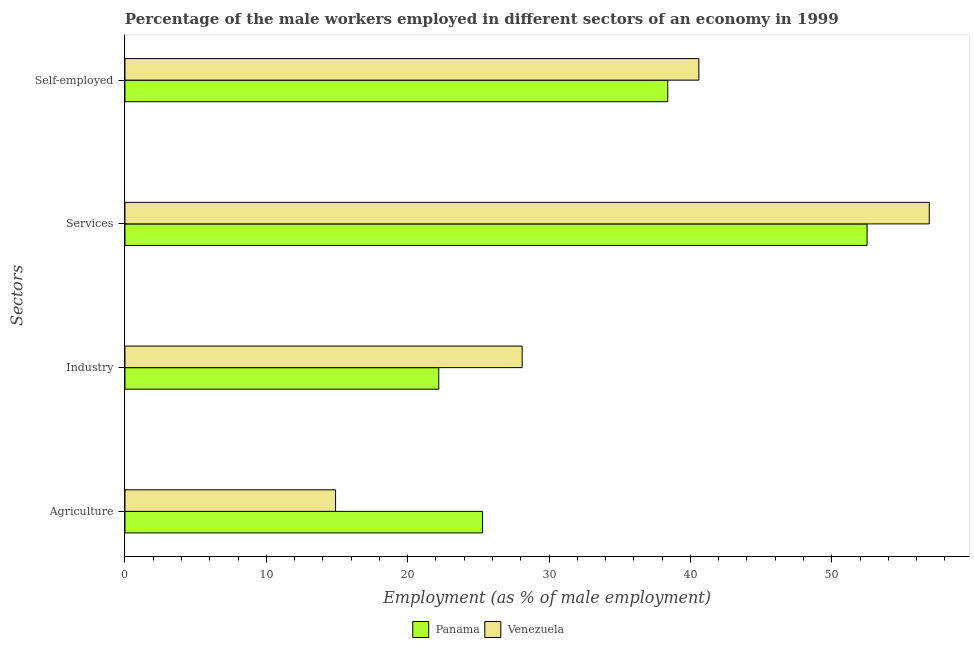How many different coloured bars are there?
Make the answer very short. 2. How many groups of bars are there?
Make the answer very short. 4. Are the number of bars on each tick of the Y-axis equal?
Provide a short and direct response. Yes. How many bars are there on the 3rd tick from the bottom?
Offer a terse response. 2. What is the label of the 3rd group of bars from the top?
Ensure brevity in your answer.  Industry. What is the percentage of male workers in industry in Panama?
Provide a short and direct response. 22.2. Across all countries, what is the maximum percentage of male workers in agriculture?
Your answer should be compact. 25.3. Across all countries, what is the minimum percentage of male workers in services?
Provide a short and direct response. 52.5. In which country was the percentage of male workers in industry maximum?
Offer a terse response. Venezuela. In which country was the percentage of self employed male workers minimum?
Offer a terse response. Panama. What is the total percentage of self employed male workers in the graph?
Your answer should be very brief. 79. What is the difference between the percentage of male workers in agriculture in Panama and that in Venezuela?
Your answer should be compact. 10.4. What is the difference between the percentage of male workers in services in Panama and the percentage of self employed male workers in Venezuela?
Make the answer very short. 11.9. What is the average percentage of male workers in services per country?
Keep it short and to the point. 54.7. What is the difference between the percentage of male workers in agriculture and percentage of male workers in industry in Venezuela?
Keep it short and to the point. -13.2. In how many countries, is the percentage of male workers in agriculture greater than 12 %?
Your answer should be very brief. 2. What is the ratio of the percentage of male workers in industry in Panama to that in Venezuela?
Give a very brief answer. 0.79. Is the percentage of male workers in industry in Panama less than that in Venezuela?
Make the answer very short. Yes. What is the difference between the highest and the second highest percentage of self employed male workers?
Your response must be concise. 2.2. What is the difference between the highest and the lowest percentage of self employed male workers?
Your answer should be compact. 2.2. In how many countries, is the percentage of male workers in agriculture greater than the average percentage of male workers in agriculture taken over all countries?
Your response must be concise. 1. Is it the case that in every country, the sum of the percentage of male workers in services and percentage of male workers in industry is greater than the sum of percentage of male workers in agriculture and percentage of self employed male workers?
Your answer should be compact. Yes. What does the 1st bar from the top in Services represents?
Ensure brevity in your answer.  Venezuela. What does the 1st bar from the bottom in Industry represents?
Ensure brevity in your answer.  Panama. Is it the case that in every country, the sum of the percentage of male workers in agriculture and percentage of male workers in industry is greater than the percentage of male workers in services?
Ensure brevity in your answer.  No. Are all the bars in the graph horizontal?
Ensure brevity in your answer.  Yes. How many countries are there in the graph?
Provide a succinct answer. 2. What is the difference between two consecutive major ticks on the X-axis?
Make the answer very short. 10. Are the values on the major ticks of X-axis written in scientific E-notation?
Provide a short and direct response. No. How are the legend labels stacked?
Keep it short and to the point. Horizontal. What is the title of the graph?
Give a very brief answer. Percentage of the male workers employed in different sectors of an economy in 1999. What is the label or title of the X-axis?
Provide a short and direct response. Employment (as % of male employment). What is the label or title of the Y-axis?
Your response must be concise. Sectors. What is the Employment (as % of male employment) of Panama in Agriculture?
Provide a succinct answer. 25.3. What is the Employment (as % of male employment) of Venezuela in Agriculture?
Your answer should be very brief. 14.9. What is the Employment (as % of male employment) in Panama in Industry?
Provide a short and direct response. 22.2. What is the Employment (as % of male employment) of Venezuela in Industry?
Offer a terse response. 28.1. What is the Employment (as % of male employment) in Panama in Services?
Provide a succinct answer. 52.5. What is the Employment (as % of male employment) in Venezuela in Services?
Your answer should be very brief. 56.9. What is the Employment (as % of male employment) in Panama in Self-employed?
Offer a terse response. 38.4. What is the Employment (as % of male employment) of Venezuela in Self-employed?
Make the answer very short. 40.6. Across all Sectors, what is the maximum Employment (as % of male employment) in Panama?
Your answer should be compact. 52.5. Across all Sectors, what is the maximum Employment (as % of male employment) in Venezuela?
Offer a terse response. 56.9. Across all Sectors, what is the minimum Employment (as % of male employment) in Panama?
Give a very brief answer. 22.2. Across all Sectors, what is the minimum Employment (as % of male employment) of Venezuela?
Offer a very short reply. 14.9. What is the total Employment (as % of male employment) of Panama in the graph?
Your answer should be very brief. 138.4. What is the total Employment (as % of male employment) of Venezuela in the graph?
Your response must be concise. 140.5. What is the difference between the Employment (as % of male employment) in Panama in Agriculture and that in Industry?
Keep it short and to the point. 3.1. What is the difference between the Employment (as % of male employment) of Venezuela in Agriculture and that in Industry?
Offer a terse response. -13.2. What is the difference between the Employment (as % of male employment) of Panama in Agriculture and that in Services?
Provide a short and direct response. -27.2. What is the difference between the Employment (as % of male employment) in Venezuela in Agriculture and that in Services?
Keep it short and to the point. -42. What is the difference between the Employment (as % of male employment) in Venezuela in Agriculture and that in Self-employed?
Keep it short and to the point. -25.7. What is the difference between the Employment (as % of male employment) of Panama in Industry and that in Services?
Keep it short and to the point. -30.3. What is the difference between the Employment (as % of male employment) in Venezuela in Industry and that in Services?
Provide a short and direct response. -28.8. What is the difference between the Employment (as % of male employment) in Panama in Industry and that in Self-employed?
Provide a short and direct response. -16.2. What is the difference between the Employment (as % of male employment) in Venezuela in Industry and that in Self-employed?
Provide a short and direct response. -12.5. What is the difference between the Employment (as % of male employment) of Venezuela in Services and that in Self-employed?
Your response must be concise. 16.3. What is the difference between the Employment (as % of male employment) in Panama in Agriculture and the Employment (as % of male employment) in Venezuela in Industry?
Your answer should be very brief. -2.8. What is the difference between the Employment (as % of male employment) of Panama in Agriculture and the Employment (as % of male employment) of Venezuela in Services?
Your answer should be very brief. -31.6. What is the difference between the Employment (as % of male employment) in Panama in Agriculture and the Employment (as % of male employment) in Venezuela in Self-employed?
Make the answer very short. -15.3. What is the difference between the Employment (as % of male employment) of Panama in Industry and the Employment (as % of male employment) of Venezuela in Services?
Provide a short and direct response. -34.7. What is the difference between the Employment (as % of male employment) of Panama in Industry and the Employment (as % of male employment) of Venezuela in Self-employed?
Provide a succinct answer. -18.4. What is the average Employment (as % of male employment) of Panama per Sectors?
Make the answer very short. 34.6. What is the average Employment (as % of male employment) of Venezuela per Sectors?
Your response must be concise. 35.12. What is the difference between the Employment (as % of male employment) of Panama and Employment (as % of male employment) of Venezuela in Services?
Make the answer very short. -4.4. What is the ratio of the Employment (as % of male employment) in Panama in Agriculture to that in Industry?
Your answer should be compact. 1.14. What is the ratio of the Employment (as % of male employment) in Venezuela in Agriculture to that in Industry?
Offer a very short reply. 0.53. What is the ratio of the Employment (as % of male employment) of Panama in Agriculture to that in Services?
Make the answer very short. 0.48. What is the ratio of the Employment (as % of male employment) in Venezuela in Agriculture to that in Services?
Offer a terse response. 0.26. What is the ratio of the Employment (as % of male employment) in Panama in Agriculture to that in Self-employed?
Provide a succinct answer. 0.66. What is the ratio of the Employment (as % of male employment) in Venezuela in Agriculture to that in Self-employed?
Provide a succinct answer. 0.37. What is the ratio of the Employment (as % of male employment) of Panama in Industry to that in Services?
Offer a terse response. 0.42. What is the ratio of the Employment (as % of male employment) of Venezuela in Industry to that in Services?
Provide a succinct answer. 0.49. What is the ratio of the Employment (as % of male employment) of Panama in Industry to that in Self-employed?
Your answer should be compact. 0.58. What is the ratio of the Employment (as % of male employment) in Venezuela in Industry to that in Self-employed?
Ensure brevity in your answer.  0.69. What is the ratio of the Employment (as % of male employment) in Panama in Services to that in Self-employed?
Offer a very short reply. 1.37. What is the ratio of the Employment (as % of male employment) in Venezuela in Services to that in Self-employed?
Offer a terse response. 1.4. What is the difference between the highest and the second highest Employment (as % of male employment) in Panama?
Give a very brief answer. 14.1. What is the difference between the highest and the lowest Employment (as % of male employment) of Panama?
Your answer should be very brief. 30.3. 